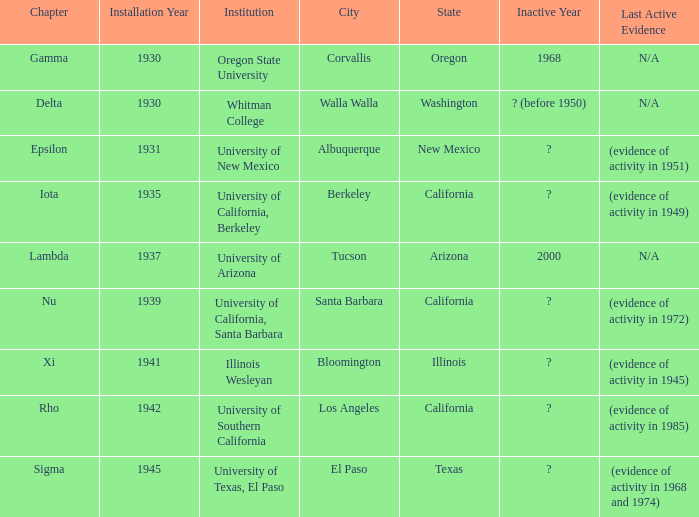What was the installation date in El Paso, Texas?  Cannot handle non-empty timestamp argument! 1945. 